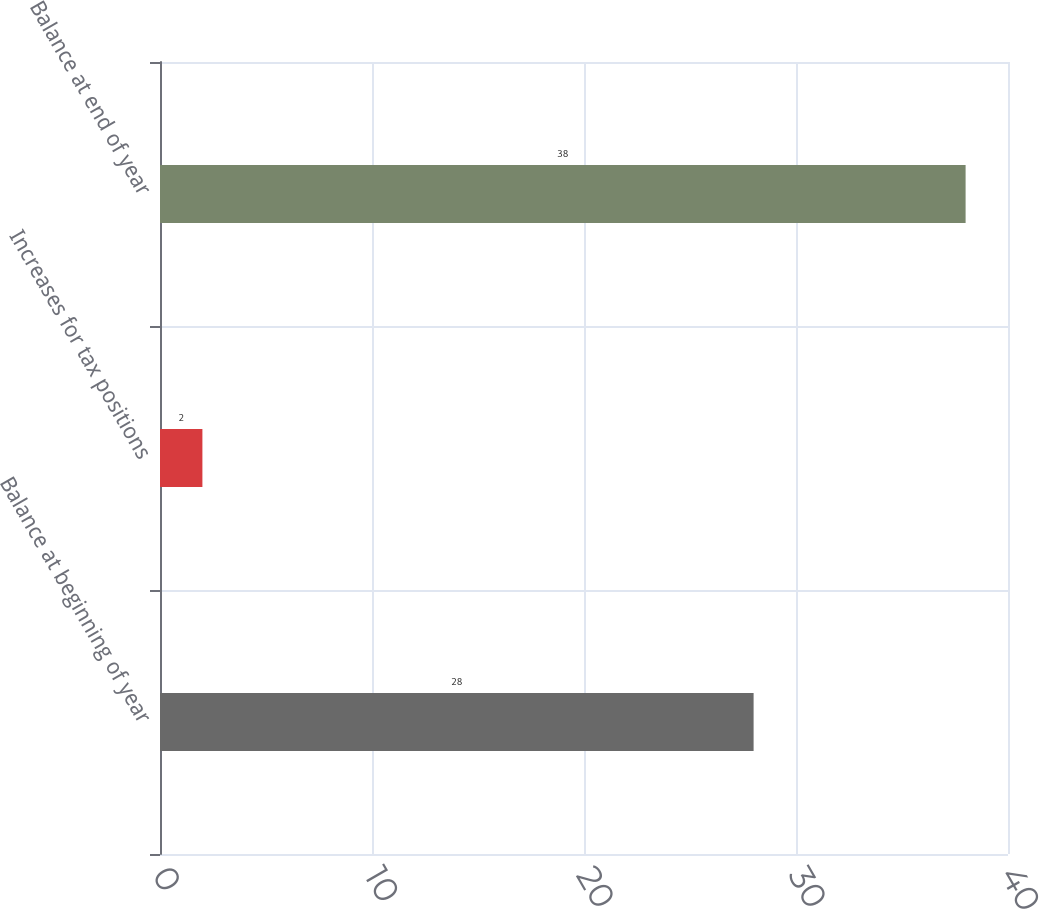<chart> <loc_0><loc_0><loc_500><loc_500><bar_chart><fcel>Balance at beginning of year<fcel>Increases for tax positions<fcel>Balance at end of year<nl><fcel>28<fcel>2<fcel>38<nl></chart> 